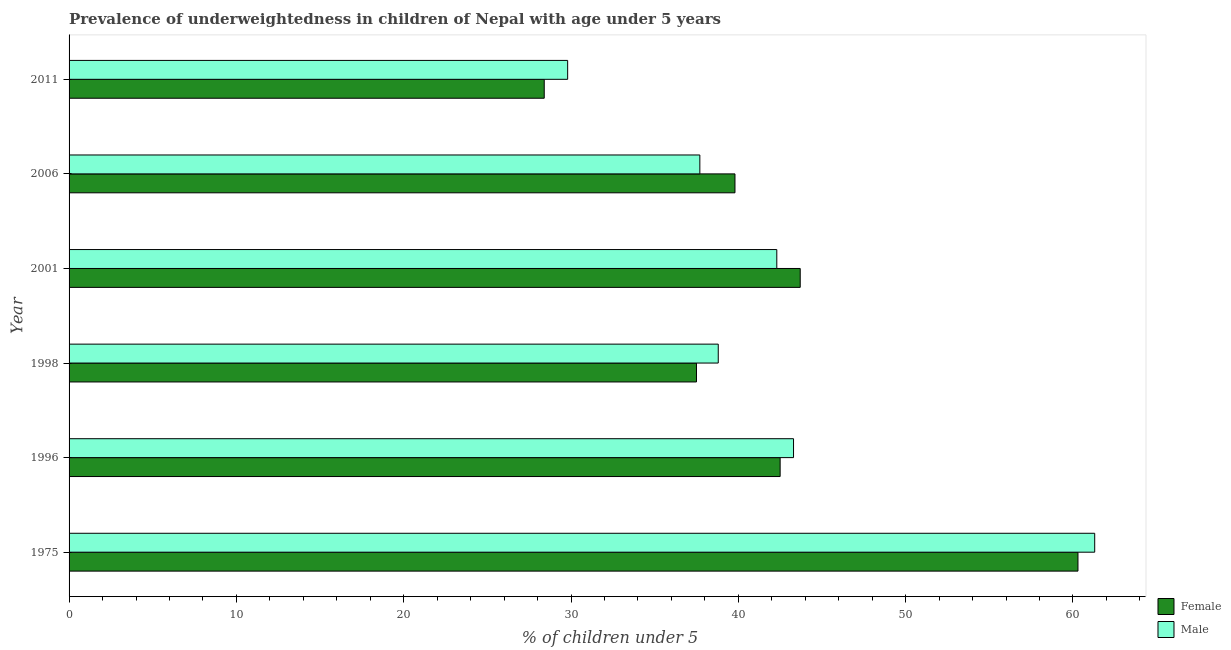Are the number of bars per tick equal to the number of legend labels?
Offer a very short reply. Yes. How many bars are there on the 2nd tick from the top?
Keep it short and to the point. 2. How many bars are there on the 4th tick from the bottom?
Provide a succinct answer. 2. What is the label of the 5th group of bars from the top?
Keep it short and to the point. 1996. What is the percentage of underweighted female children in 2006?
Offer a very short reply. 39.8. Across all years, what is the maximum percentage of underweighted female children?
Make the answer very short. 60.3. Across all years, what is the minimum percentage of underweighted male children?
Offer a terse response. 29.8. In which year was the percentage of underweighted male children maximum?
Give a very brief answer. 1975. In which year was the percentage of underweighted male children minimum?
Offer a terse response. 2011. What is the total percentage of underweighted male children in the graph?
Keep it short and to the point. 253.2. What is the difference between the percentage of underweighted male children in 1996 and the percentage of underweighted female children in 2006?
Offer a very short reply. 3.5. What is the average percentage of underweighted male children per year?
Provide a succinct answer. 42.2. What is the ratio of the percentage of underweighted female children in 1996 to that in 1998?
Keep it short and to the point. 1.13. Is the percentage of underweighted male children in 1996 less than that in 1998?
Provide a succinct answer. No. What is the difference between the highest and the second highest percentage of underweighted female children?
Your answer should be very brief. 16.6. What is the difference between the highest and the lowest percentage of underweighted female children?
Provide a succinct answer. 31.9. In how many years, is the percentage of underweighted male children greater than the average percentage of underweighted male children taken over all years?
Keep it short and to the point. 3. Is the sum of the percentage of underweighted female children in 2006 and 2011 greater than the maximum percentage of underweighted male children across all years?
Provide a succinct answer. Yes. What does the 1st bar from the top in 2006 represents?
Make the answer very short. Male. What does the 2nd bar from the bottom in 2001 represents?
Your response must be concise. Male. How many bars are there?
Make the answer very short. 12. Are all the bars in the graph horizontal?
Give a very brief answer. Yes. How many years are there in the graph?
Provide a short and direct response. 6. What is the difference between two consecutive major ticks on the X-axis?
Keep it short and to the point. 10. Does the graph contain any zero values?
Make the answer very short. No. Does the graph contain grids?
Provide a succinct answer. No. How many legend labels are there?
Provide a succinct answer. 2. How are the legend labels stacked?
Ensure brevity in your answer.  Vertical. What is the title of the graph?
Give a very brief answer. Prevalence of underweightedness in children of Nepal with age under 5 years. What is the label or title of the X-axis?
Offer a terse response.  % of children under 5. What is the label or title of the Y-axis?
Provide a succinct answer. Year. What is the  % of children under 5 in Female in 1975?
Your response must be concise. 60.3. What is the  % of children under 5 in Male in 1975?
Ensure brevity in your answer.  61.3. What is the  % of children under 5 of Female in 1996?
Provide a succinct answer. 42.5. What is the  % of children under 5 of Male in 1996?
Make the answer very short. 43.3. What is the  % of children under 5 in Female in 1998?
Provide a succinct answer. 37.5. What is the  % of children under 5 of Male in 1998?
Ensure brevity in your answer.  38.8. What is the  % of children under 5 of Female in 2001?
Keep it short and to the point. 43.7. What is the  % of children under 5 in Male in 2001?
Offer a terse response. 42.3. What is the  % of children under 5 in Female in 2006?
Keep it short and to the point. 39.8. What is the  % of children under 5 of Male in 2006?
Make the answer very short. 37.7. What is the  % of children under 5 of Female in 2011?
Your answer should be compact. 28.4. What is the  % of children under 5 of Male in 2011?
Offer a very short reply. 29.8. Across all years, what is the maximum  % of children under 5 of Female?
Offer a very short reply. 60.3. Across all years, what is the maximum  % of children under 5 in Male?
Keep it short and to the point. 61.3. Across all years, what is the minimum  % of children under 5 of Female?
Provide a short and direct response. 28.4. Across all years, what is the minimum  % of children under 5 of Male?
Offer a terse response. 29.8. What is the total  % of children under 5 in Female in the graph?
Your answer should be very brief. 252.2. What is the total  % of children under 5 in Male in the graph?
Offer a terse response. 253.2. What is the difference between the  % of children under 5 of Male in 1975 and that in 1996?
Your answer should be very brief. 18. What is the difference between the  % of children under 5 in Female in 1975 and that in 1998?
Offer a very short reply. 22.8. What is the difference between the  % of children under 5 in Male in 1975 and that in 1998?
Offer a terse response. 22.5. What is the difference between the  % of children under 5 in Male in 1975 and that in 2001?
Offer a terse response. 19. What is the difference between the  % of children under 5 in Male in 1975 and that in 2006?
Offer a very short reply. 23.6. What is the difference between the  % of children under 5 in Female in 1975 and that in 2011?
Your response must be concise. 31.9. What is the difference between the  % of children under 5 of Male in 1975 and that in 2011?
Give a very brief answer. 31.5. What is the difference between the  % of children under 5 of Male in 1996 and that in 2001?
Provide a short and direct response. 1. What is the difference between the  % of children under 5 in Female in 1996 and that in 2006?
Offer a terse response. 2.7. What is the difference between the  % of children under 5 of Female in 1996 and that in 2011?
Your answer should be very brief. 14.1. What is the difference between the  % of children under 5 in Male in 1996 and that in 2011?
Your response must be concise. 13.5. What is the difference between the  % of children under 5 of Female in 1998 and that in 2001?
Provide a succinct answer. -6.2. What is the difference between the  % of children under 5 in Female in 1998 and that in 2006?
Your answer should be very brief. -2.3. What is the difference between the  % of children under 5 in Female in 1998 and that in 2011?
Offer a very short reply. 9.1. What is the difference between the  % of children under 5 in Male in 1998 and that in 2011?
Your response must be concise. 9. What is the difference between the  % of children under 5 of Female in 2001 and that in 2006?
Ensure brevity in your answer.  3.9. What is the difference between the  % of children under 5 in Male in 2001 and that in 2006?
Provide a succinct answer. 4.6. What is the difference between the  % of children under 5 of Male in 2001 and that in 2011?
Give a very brief answer. 12.5. What is the difference between the  % of children under 5 in Female in 2006 and that in 2011?
Give a very brief answer. 11.4. What is the difference between the  % of children under 5 of Male in 2006 and that in 2011?
Offer a terse response. 7.9. What is the difference between the  % of children under 5 in Female in 1975 and the  % of children under 5 in Male in 1996?
Make the answer very short. 17. What is the difference between the  % of children under 5 in Female in 1975 and the  % of children under 5 in Male in 1998?
Provide a short and direct response. 21.5. What is the difference between the  % of children under 5 of Female in 1975 and the  % of children under 5 of Male in 2001?
Your response must be concise. 18. What is the difference between the  % of children under 5 of Female in 1975 and the  % of children under 5 of Male in 2006?
Ensure brevity in your answer.  22.6. What is the difference between the  % of children under 5 of Female in 1975 and the  % of children under 5 of Male in 2011?
Ensure brevity in your answer.  30.5. What is the difference between the  % of children under 5 of Female in 1998 and the  % of children under 5 of Male in 2011?
Keep it short and to the point. 7.7. What is the difference between the  % of children under 5 in Female in 2001 and the  % of children under 5 in Male in 2006?
Your answer should be very brief. 6. What is the difference between the  % of children under 5 in Female in 2001 and the  % of children under 5 in Male in 2011?
Your answer should be compact. 13.9. What is the difference between the  % of children under 5 in Female in 2006 and the  % of children under 5 in Male in 2011?
Provide a succinct answer. 10. What is the average  % of children under 5 of Female per year?
Provide a short and direct response. 42.03. What is the average  % of children under 5 of Male per year?
Keep it short and to the point. 42.2. In the year 1975, what is the difference between the  % of children under 5 in Female and  % of children under 5 in Male?
Your answer should be compact. -1. In the year 2006, what is the difference between the  % of children under 5 in Female and  % of children under 5 in Male?
Your answer should be very brief. 2.1. In the year 2011, what is the difference between the  % of children under 5 in Female and  % of children under 5 in Male?
Ensure brevity in your answer.  -1.4. What is the ratio of the  % of children under 5 in Female in 1975 to that in 1996?
Offer a terse response. 1.42. What is the ratio of the  % of children under 5 in Male in 1975 to that in 1996?
Your answer should be very brief. 1.42. What is the ratio of the  % of children under 5 in Female in 1975 to that in 1998?
Offer a very short reply. 1.61. What is the ratio of the  % of children under 5 of Male in 1975 to that in 1998?
Your answer should be very brief. 1.58. What is the ratio of the  % of children under 5 in Female in 1975 to that in 2001?
Give a very brief answer. 1.38. What is the ratio of the  % of children under 5 in Male in 1975 to that in 2001?
Your response must be concise. 1.45. What is the ratio of the  % of children under 5 in Female in 1975 to that in 2006?
Your response must be concise. 1.52. What is the ratio of the  % of children under 5 in Male in 1975 to that in 2006?
Keep it short and to the point. 1.63. What is the ratio of the  % of children under 5 in Female in 1975 to that in 2011?
Provide a short and direct response. 2.12. What is the ratio of the  % of children under 5 of Male in 1975 to that in 2011?
Offer a very short reply. 2.06. What is the ratio of the  % of children under 5 in Female in 1996 to that in 1998?
Ensure brevity in your answer.  1.13. What is the ratio of the  % of children under 5 of Male in 1996 to that in 1998?
Offer a terse response. 1.12. What is the ratio of the  % of children under 5 of Female in 1996 to that in 2001?
Your answer should be very brief. 0.97. What is the ratio of the  % of children under 5 of Male in 1996 to that in 2001?
Provide a short and direct response. 1.02. What is the ratio of the  % of children under 5 of Female in 1996 to that in 2006?
Offer a terse response. 1.07. What is the ratio of the  % of children under 5 in Male in 1996 to that in 2006?
Your answer should be very brief. 1.15. What is the ratio of the  % of children under 5 of Female in 1996 to that in 2011?
Provide a short and direct response. 1.5. What is the ratio of the  % of children under 5 in Male in 1996 to that in 2011?
Your answer should be very brief. 1.45. What is the ratio of the  % of children under 5 in Female in 1998 to that in 2001?
Offer a very short reply. 0.86. What is the ratio of the  % of children under 5 of Male in 1998 to that in 2001?
Offer a terse response. 0.92. What is the ratio of the  % of children under 5 of Female in 1998 to that in 2006?
Your answer should be very brief. 0.94. What is the ratio of the  % of children under 5 of Male in 1998 to that in 2006?
Provide a succinct answer. 1.03. What is the ratio of the  % of children under 5 in Female in 1998 to that in 2011?
Give a very brief answer. 1.32. What is the ratio of the  % of children under 5 in Male in 1998 to that in 2011?
Offer a very short reply. 1.3. What is the ratio of the  % of children under 5 in Female in 2001 to that in 2006?
Offer a terse response. 1.1. What is the ratio of the  % of children under 5 of Male in 2001 to that in 2006?
Provide a succinct answer. 1.12. What is the ratio of the  % of children under 5 in Female in 2001 to that in 2011?
Your answer should be very brief. 1.54. What is the ratio of the  % of children under 5 of Male in 2001 to that in 2011?
Your response must be concise. 1.42. What is the ratio of the  % of children under 5 of Female in 2006 to that in 2011?
Keep it short and to the point. 1.4. What is the ratio of the  % of children under 5 of Male in 2006 to that in 2011?
Your response must be concise. 1.27. What is the difference between the highest and the second highest  % of children under 5 of Male?
Provide a short and direct response. 18. What is the difference between the highest and the lowest  % of children under 5 of Female?
Provide a succinct answer. 31.9. What is the difference between the highest and the lowest  % of children under 5 of Male?
Offer a very short reply. 31.5. 